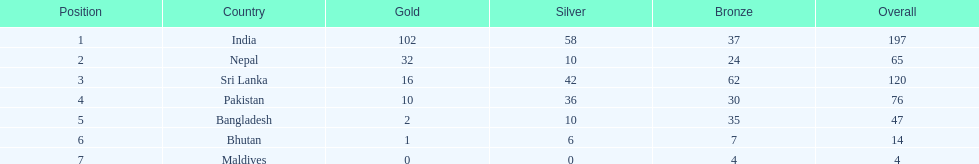What is the difference in total number of medals between india and nepal? 132. 